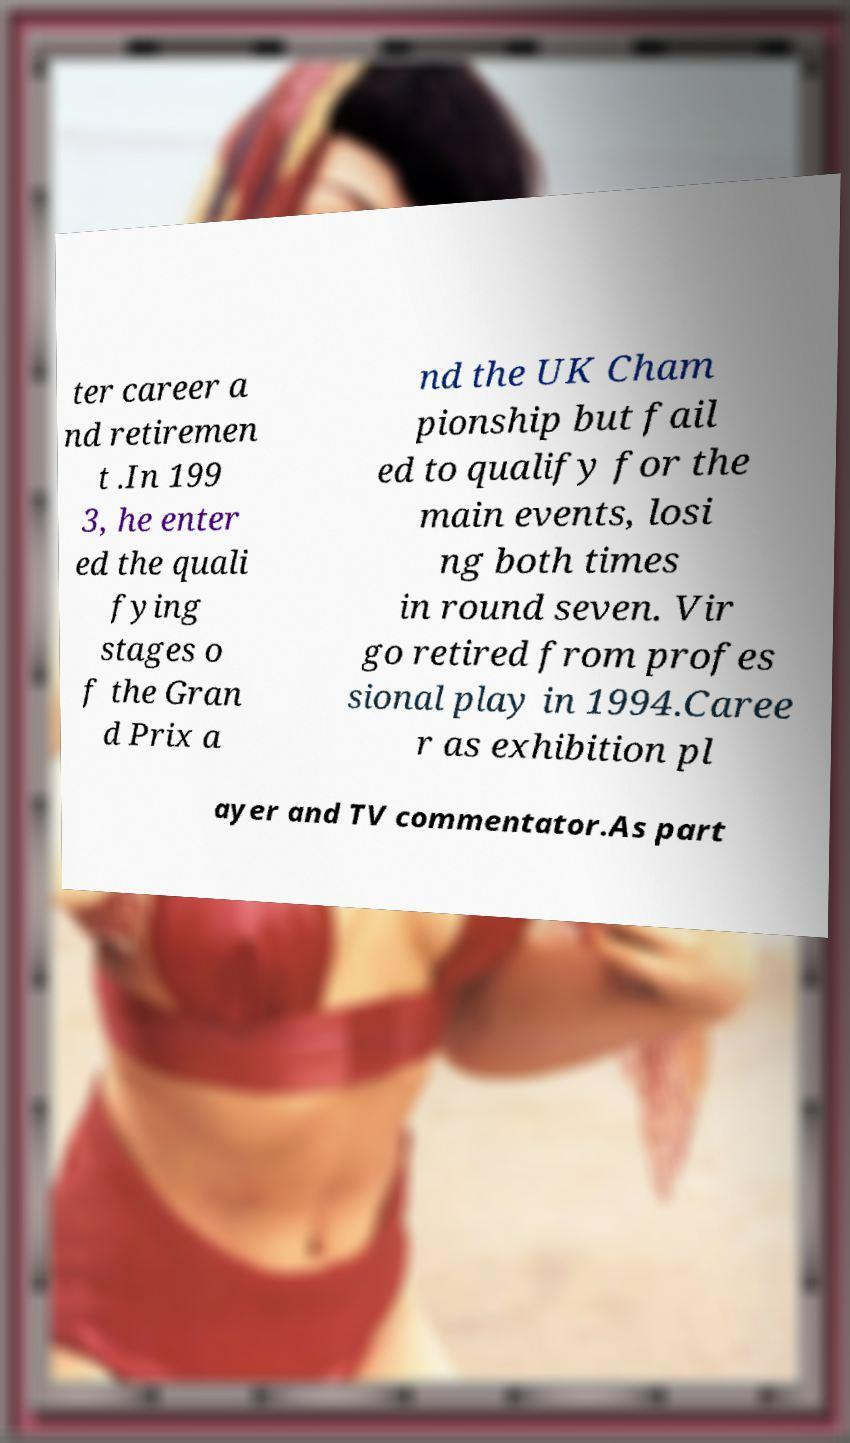Could you extract and type out the text from this image? ter career a nd retiremen t .In 199 3, he enter ed the quali fying stages o f the Gran d Prix a nd the UK Cham pionship but fail ed to qualify for the main events, losi ng both times in round seven. Vir go retired from profes sional play in 1994.Caree r as exhibition pl ayer and TV commentator.As part 